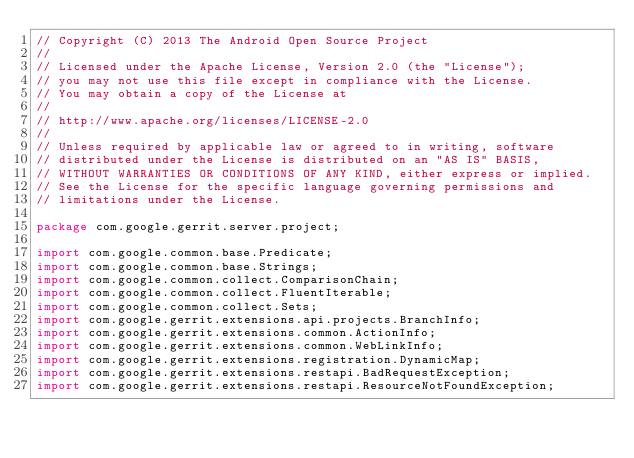<code> <loc_0><loc_0><loc_500><loc_500><_Java_>// Copyright (C) 2013 The Android Open Source Project
//
// Licensed under the Apache License, Version 2.0 (the "License");
// you may not use this file except in compliance with the License.
// You may obtain a copy of the License at
//
// http://www.apache.org/licenses/LICENSE-2.0
//
// Unless required by applicable law or agreed to in writing, software
// distributed under the License is distributed on an "AS IS" BASIS,
// WITHOUT WARRANTIES OR CONDITIONS OF ANY KIND, either express or implied.
// See the License for the specific language governing permissions and
// limitations under the License.

package com.google.gerrit.server.project;

import com.google.common.base.Predicate;
import com.google.common.base.Strings;
import com.google.common.collect.ComparisonChain;
import com.google.common.collect.FluentIterable;
import com.google.common.collect.Sets;
import com.google.gerrit.extensions.api.projects.BranchInfo;
import com.google.gerrit.extensions.common.ActionInfo;
import com.google.gerrit.extensions.common.WebLinkInfo;
import com.google.gerrit.extensions.registration.DynamicMap;
import com.google.gerrit.extensions.restapi.BadRequestException;
import com.google.gerrit.extensions.restapi.ResourceNotFoundException;</code> 